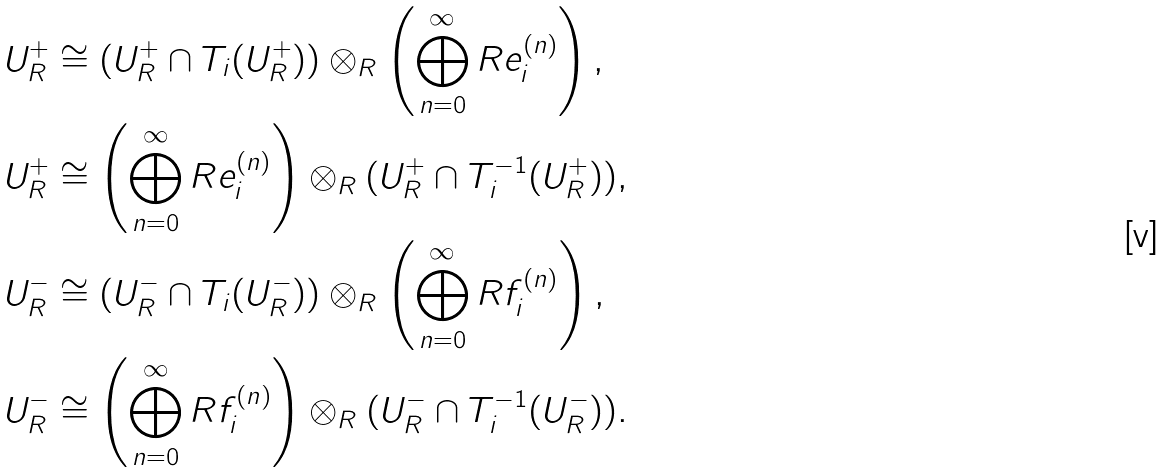Convert formula to latex. <formula><loc_0><loc_0><loc_500><loc_500>& U _ { R } ^ { + } \cong ( U _ { R } ^ { + } \cap T _ { i } ( U _ { R } ^ { + } ) ) \otimes _ { R } \left ( \bigoplus _ { n = 0 } ^ { \infty } R e _ { i } ^ { ( n ) } \right ) , \\ & U _ { R } ^ { + } \cong \left ( \bigoplus _ { n = 0 } ^ { \infty } R e _ { i } ^ { ( n ) } \right ) \otimes _ { R } ( U _ { R } ^ { + } \cap T _ { i } ^ { - 1 } ( U _ { R } ^ { + } ) ) , \\ & U _ { R } ^ { - } \cong ( U _ { R } ^ { - } \cap T _ { i } ( U _ { R } ^ { - } ) ) \otimes _ { R } \left ( \bigoplus _ { n = 0 } ^ { \infty } R f _ { i } ^ { ( n ) } \right ) , \\ & U _ { R } ^ { - } \cong \left ( \bigoplus _ { n = 0 } ^ { \infty } R f _ { i } ^ { ( n ) } \right ) \otimes _ { R } ( U _ { R } ^ { - } \cap T _ { i } ^ { - 1 } ( U _ { R } ^ { - } ) ) .</formula> 